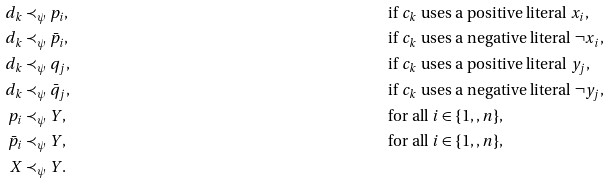Convert formula to latex. <formula><loc_0><loc_0><loc_500><loc_500>d _ { k } & \prec _ { \psi } p _ { i } , & & \text {if $c_{k}$ uses a positive literal $x_{i}$} , \\ d _ { k } & \prec _ { \psi } \bar { p } _ { i } , & & \text {if $c_{k}$ uses a negative literal $\neg x_{i}$} , \\ d _ { k } & \prec _ { \psi } q _ { j } , & & \text {if $c_{k}$ uses a positive literal $y_{j}$} , \\ d _ { k } & \prec _ { \psi } \bar { q } _ { j } , & & \text {if $c_{k}$ uses a negative literal $\neg y_{j}$} , \\ p _ { i } & \prec _ { \psi } Y , & & \text {for all $i\in\{1,,n\}$} , \\ \bar { p } _ { i } & \prec _ { \psi } Y , & & \text {for all $i\in\{1,,n\}$} , \\ X & \prec _ { \psi } Y .</formula> 